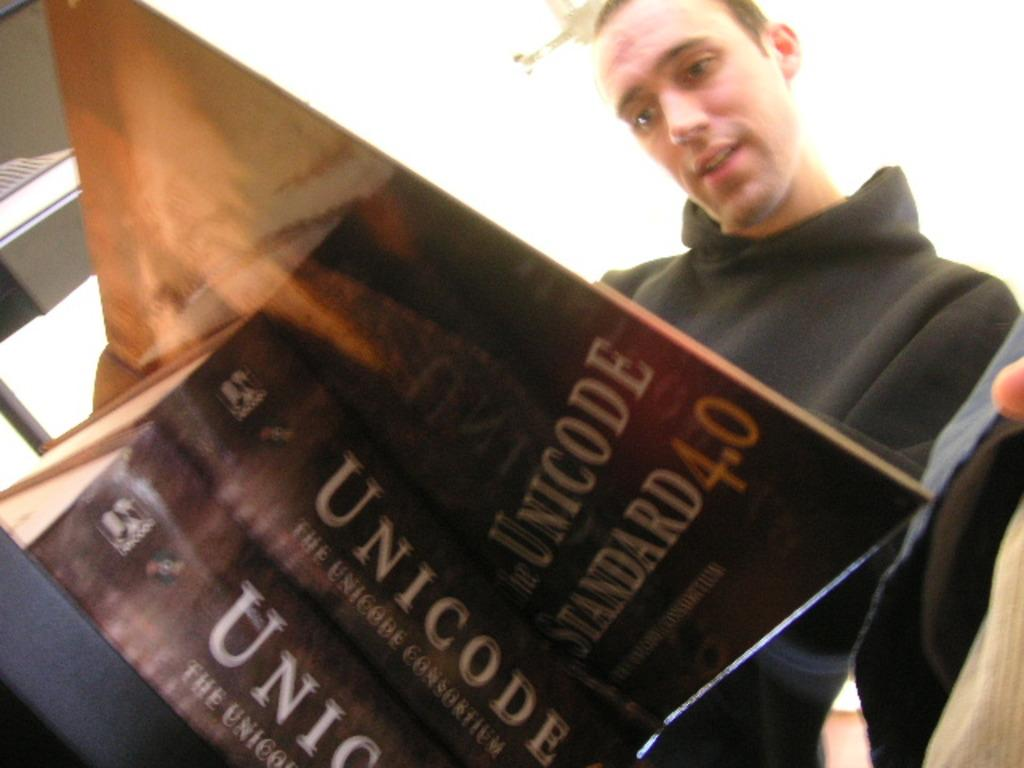Who or what is present in the image? There is a person in the image. What is the person wearing? The person is wearing a black dress. How many books are visible in the image? There are three brown-colored books in the image. What is the color of the object on which the books are placed? The books are on a black-colored object. What type of coal is being used to power the person's nerves in the image? There is no coal or mention of nerves in the image; it features a person wearing a black dress and three brown-colored books on a black-colored object. 